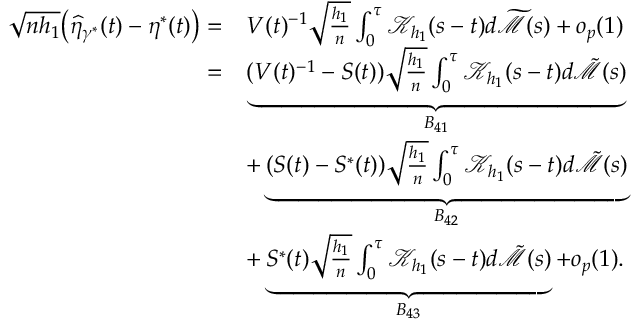Convert formula to latex. <formula><loc_0><loc_0><loc_500><loc_500>\begin{array} { r l } { \sqrt { n h _ { 1 } } \left ( \widehat { \eta } _ { \gamma ^ { * } } ( t ) - \eta ^ { * } ( t ) \right ) = } & { V ( t ) ^ { - 1 } \sqrt { \frac { h _ { 1 } } { n } } \int _ { 0 } ^ { \tau } \mathcal { K } _ { h _ { 1 } } ( s - t ) d \widetilde { \mathcal { M } } ( s ) + o _ { p } ( 1 ) } \\ { = } & { \underbrace { ( V ( t ) ^ { - 1 } - S ( t ) ) \sqrt { \frac { h _ { 1 } } { n } } \int _ { 0 } ^ { \tau } \mathcal { K } _ { h _ { 1 } } ( s - t ) d \tilde { \mathcal { M } } ( s ) } _ { B _ { 4 1 } } } \\ & { + \underbrace { ( S ( t ) - S ^ { * } ( t ) ) \sqrt { \frac { h _ { 1 } } { n } } \int _ { 0 } ^ { \tau } \mathcal { K } _ { h _ { 1 } } ( s - t ) d \tilde { \mathcal { M } } ( s ) } _ { B _ { 4 2 } } } \\ & { + \underbrace { S ^ { * } ( t ) \sqrt { \frac { h _ { 1 } } { n } } \int _ { 0 } ^ { \tau } \mathcal { K } _ { h _ { 1 } } ( s - t ) d \tilde { \mathcal { M } } ( s ) } _ { B _ { 4 3 } } + o _ { p } ( 1 ) . } \end{array}</formula> 